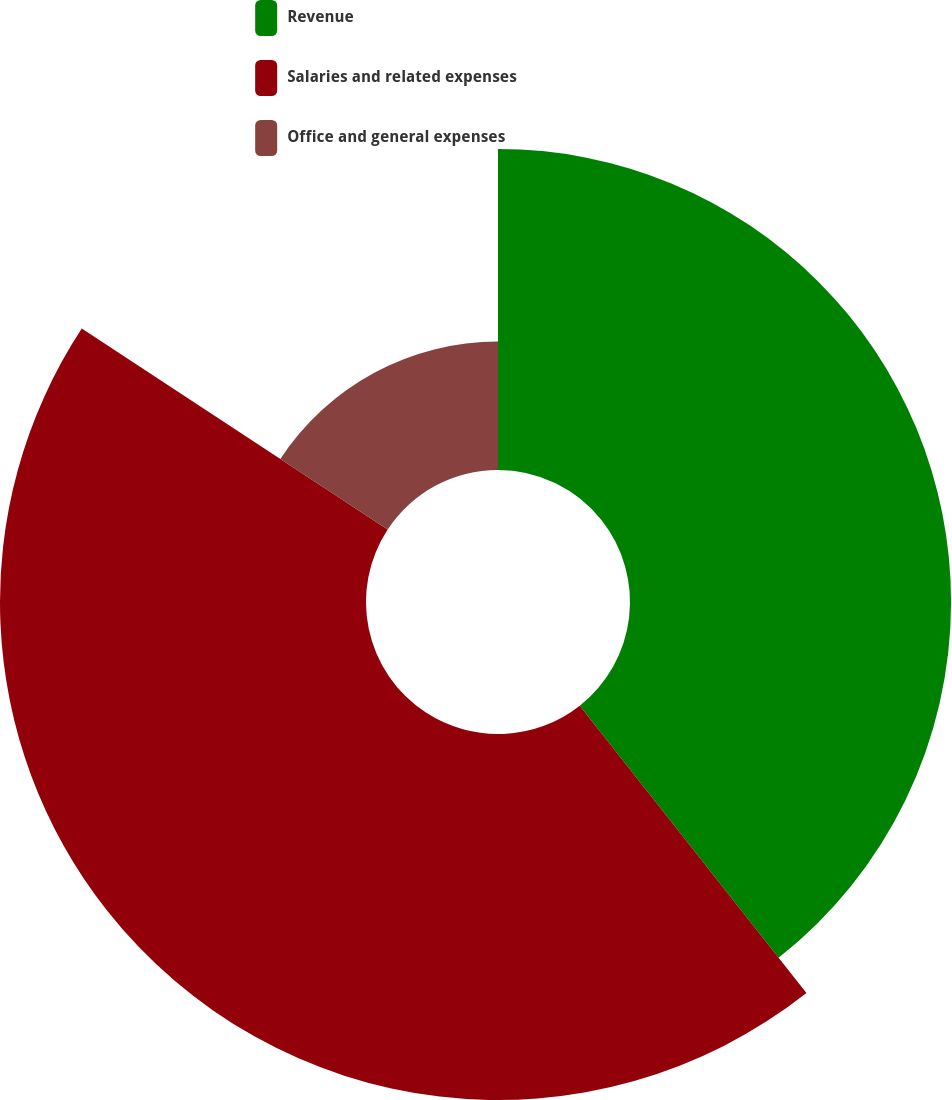Convert chart. <chart><loc_0><loc_0><loc_500><loc_500><pie_chart><fcel>Revenue<fcel>Salaries and related expenses<fcel>Office and general expenses<nl><fcel>39.37%<fcel>44.88%<fcel>15.75%<nl></chart> 